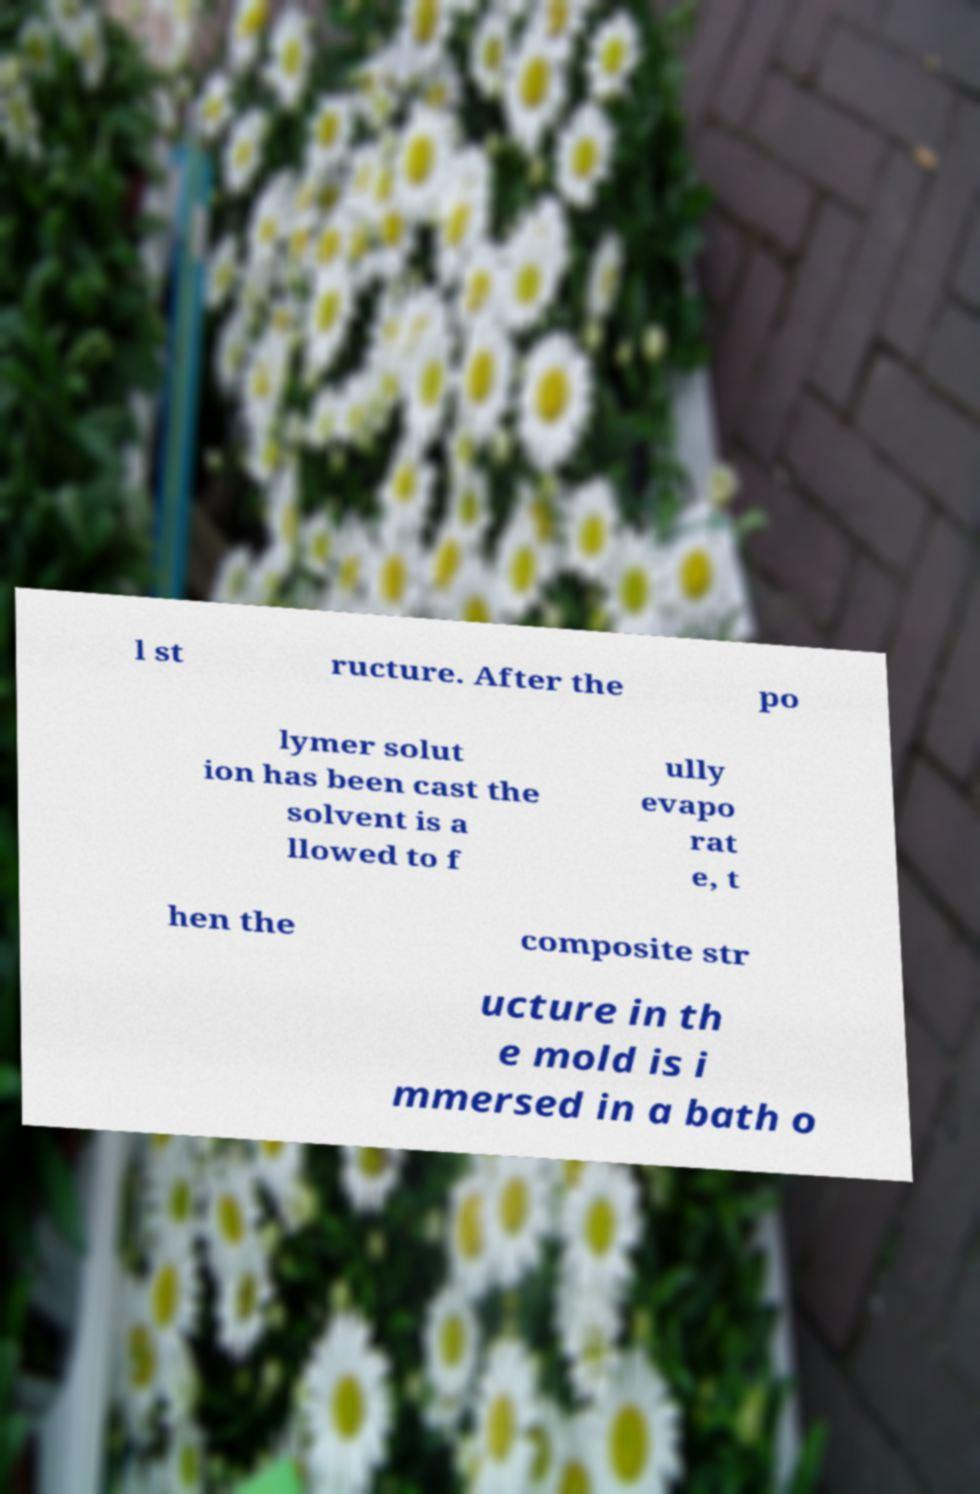For documentation purposes, I need the text within this image transcribed. Could you provide that? l st ructure. After the po lymer solut ion has been cast the solvent is a llowed to f ully evapo rat e, t hen the composite str ucture in th e mold is i mmersed in a bath o 